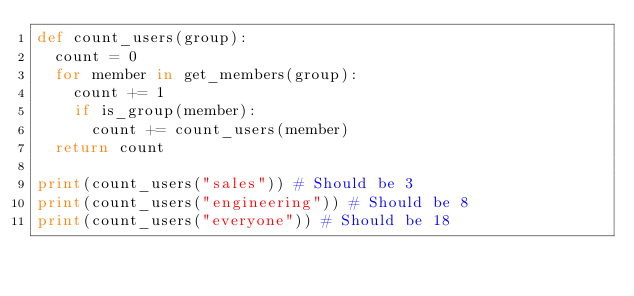Convert code to text. <code><loc_0><loc_0><loc_500><loc_500><_Python_>def count_users(group):
  count = 0
  for member in get_members(group):
    count += 1
    if is_group(member):
      count += count_users(member)
  return count

print(count_users("sales")) # Should be 3
print(count_users("engineering")) # Should be 8
print(count_users("everyone")) # Should be 18
</code> 